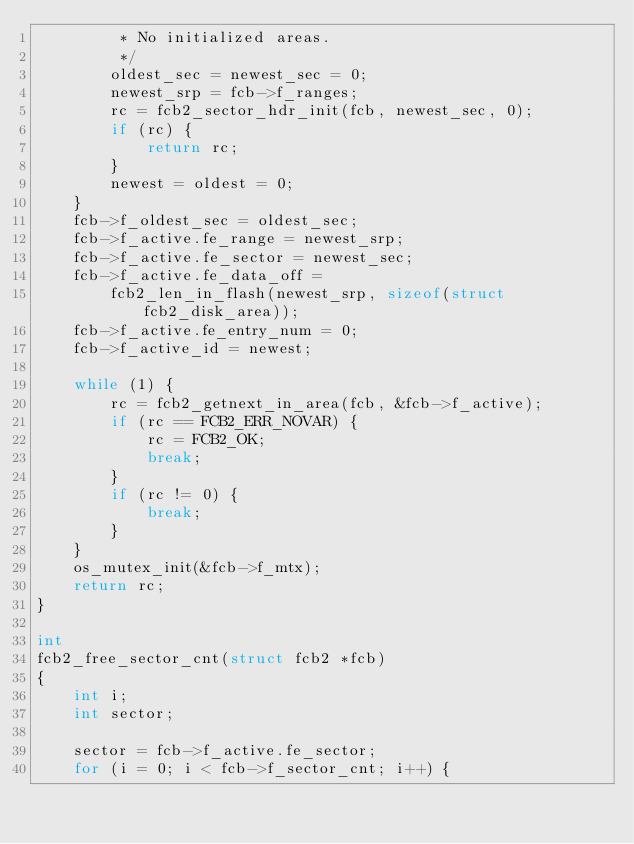Convert code to text. <code><loc_0><loc_0><loc_500><loc_500><_C_>         * No initialized areas.
         */
        oldest_sec = newest_sec = 0;
        newest_srp = fcb->f_ranges;
        rc = fcb2_sector_hdr_init(fcb, newest_sec, 0);
        if (rc) {
            return rc;
        }
        newest = oldest = 0;
    }
    fcb->f_oldest_sec = oldest_sec;
    fcb->f_active.fe_range = newest_srp;
    fcb->f_active.fe_sector = newest_sec;
    fcb->f_active.fe_data_off =
        fcb2_len_in_flash(newest_srp, sizeof(struct fcb2_disk_area));
    fcb->f_active.fe_entry_num = 0;
    fcb->f_active_id = newest;

    while (1) {
        rc = fcb2_getnext_in_area(fcb, &fcb->f_active);
        if (rc == FCB2_ERR_NOVAR) {
            rc = FCB2_OK;
            break;
        }
        if (rc != 0) {
            break;
        }
    }
    os_mutex_init(&fcb->f_mtx);
    return rc;
}

int
fcb2_free_sector_cnt(struct fcb2 *fcb)
{
    int i;
    int sector;

    sector = fcb->f_active.fe_sector;
    for (i = 0; i < fcb->f_sector_cnt; i++) {</code> 